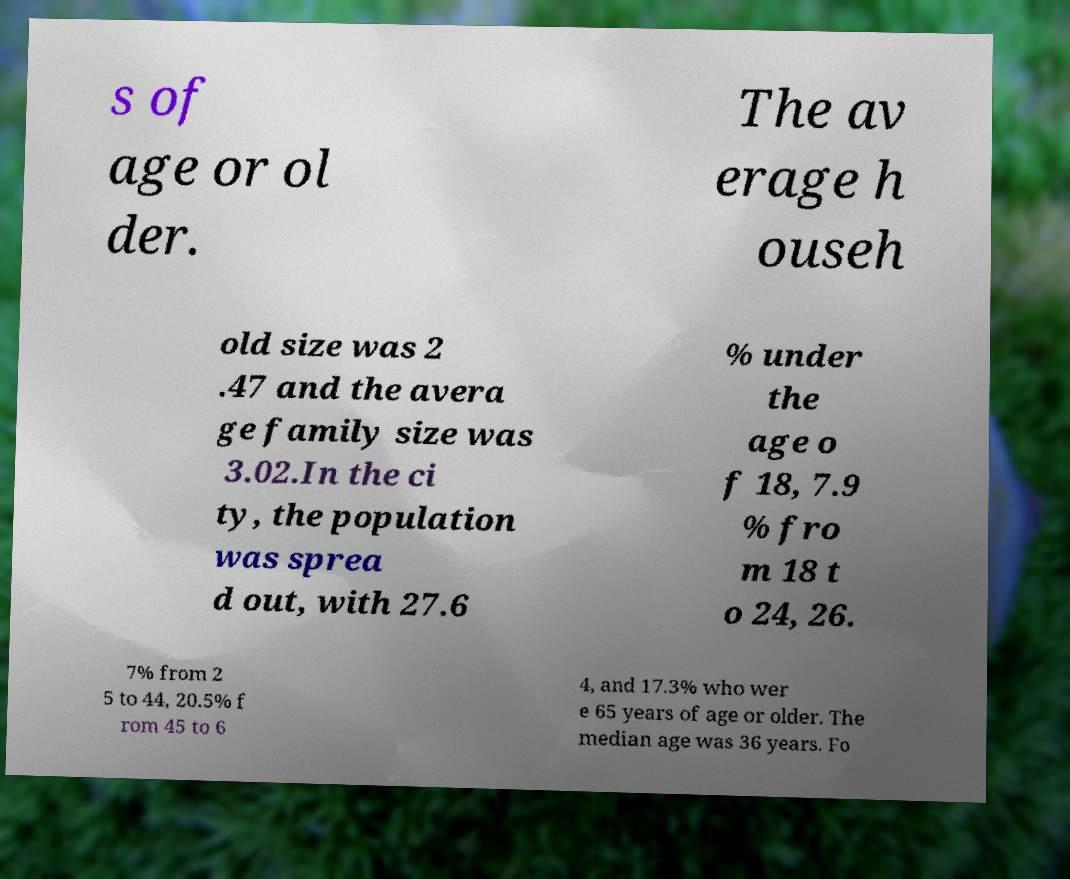Please read and relay the text visible in this image. What does it say? s of age or ol der. The av erage h ouseh old size was 2 .47 and the avera ge family size was 3.02.In the ci ty, the population was sprea d out, with 27.6 % under the age o f 18, 7.9 % fro m 18 t o 24, 26. 7% from 2 5 to 44, 20.5% f rom 45 to 6 4, and 17.3% who wer e 65 years of age or older. The median age was 36 years. Fo 